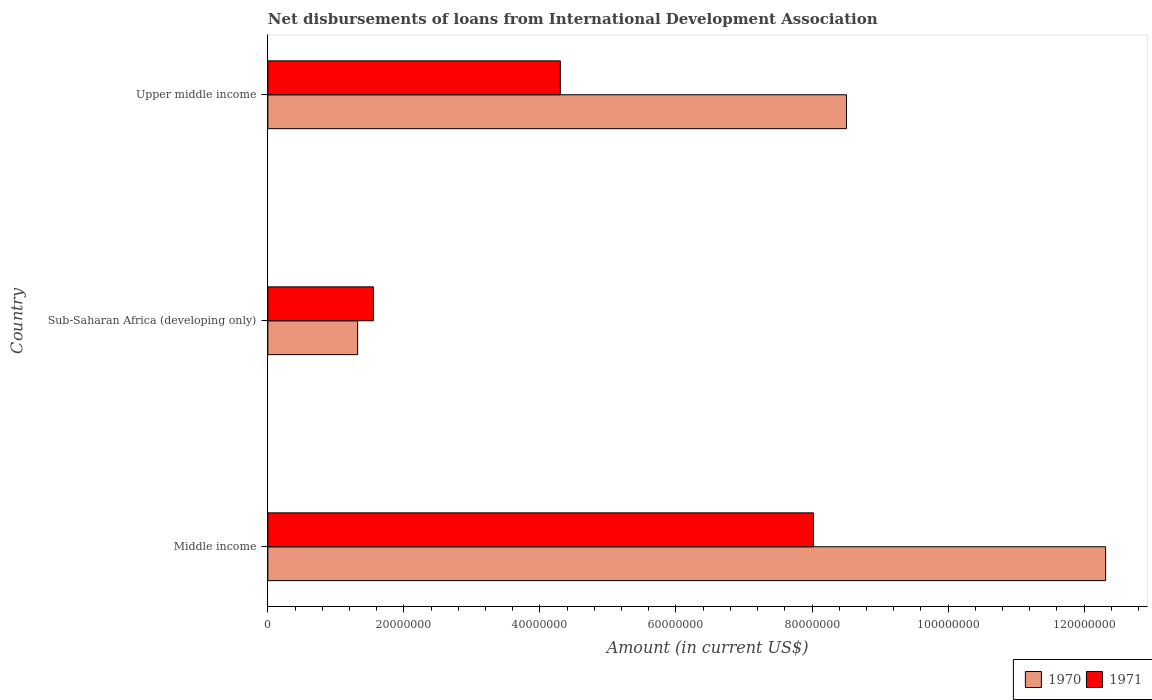How many groups of bars are there?
Make the answer very short. 3. Are the number of bars per tick equal to the number of legend labels?
Your response must be concise. Yes. Are the number of bars on each tick of the Y-axis equal?
Keep it short and to the point. Yes. How many bars are there on the 2nd tick from the top?
Your answer should be compact. 2. In how many cases, is the number of bars for a given country not equal to the number of legend labels?
Your response must be concise. 0. What is the amount of loans disbursed in 1971 in Middle income?
Provide a succinct answer. 8.02e+07. Across all countries, what is the maximum amount of loans disbursed in 1971?
Offer a very short reply. 8.02e+07. Across all countries, what is the minimum amount of loans disbursed in 1970?
Offer a very short reply. 1.32e+07. In which country was the amount of loans disbursed in 1970 minimum?
Give a very brief answer. Sub-Saharan Africa (developing only). What is the total amount of loans disbursed in 1970 in the graph?
Offer a very short reply. 2.21e+08. What is the difference between the amount of loans disbursed in 1970 in Middle income and that in Sub-Saharan Africa (developing only)?
Your response must be concise. 1.10e+08. What is the difference between the amount of loans disbursed in 1971 in Upper middle income and the amount of loans disbursed in 1970 in Sub-Saharan Africa (developing only)?
Your answer should be compact. 2.98e+07. What is the average amount of loans disbursed in 1970 per country?
Your answer should be very brief. 7.38e+07. What is the difference between the amount of loans disbursed in 1971 and amount of loans disbursed in 1970 in Sub-Saharan Africa (developing only)?
Provide a succinct answer. 2.31e+06. In how many countries, is the amount of loans disbursed in 1971 greater than 4000000 US$?
Keep it short and to the point. 3. What is the ratio of the amount of loans disbursed in 1970 in Sub-Saharan Africa (developing only) to that in Upper middle income?
Offer a terse response. 0.16. Is the amount of loans disbursed in 1970 in Middle income less than that in Sub-Saharan Africa (developing only)?
Provide a short and direct response. No. Is the difference between the amount of loans disbursed in 1971 in Middle income and Upper middle income greater than the difference between the amount of loans disbursed in 1970 in Middle income and Upper middle income?
Your response must be concise. No. What is the difference between the highest and the second highest amount of loans disbursed in 1971?
Give a very brief answer. 3.72e+07. What is the difference between the highest and the lowest amount of loans disbursed in 1970?
Your response must be concise. 1.10e+08. In how many countries, is the amount of loans disbursed in 1970 greater than the average amount of loans disbursed in 1970 taken over all countries?
Keep it short and to the point. 2. Is the sum of the amount of loans disbursed in 1970 in Middle income and Sub-Saharan Africa (developing only) greater than the maximum amount of loans disbursed in 1971 across all countries?
Provide a short and direct response. Yes. What does the 1st bar from the top in Middle income represents?
Ensure brevity in your answer.  1971. What does the 1st bar from the bottom in Upper middle income represents?
Make the answer very short. 1970. How many countries are there in the graph?
Keep it short and to the point. 3. What is the difference between two consecutive major ticks on the X-axis?
Make the answer very short. 2.00e+07. Are the values on the major ticks of X-axis written in scientific E-notation?
Offer a terse response. No. How many legend labels are there?
Offer a terse response. 2. How are the legend labels stacked?
Your answer should be very brief. Horizontal. What is the title of the graph?
Keep it short and to the point. Net disbursements of loans from International Development Association. Does "1975" appear as one of the legend labels in the graph?
Ensure brevity in your answer.  No. What is the label or title of the X-axis?
Your answer should be compact. Amount (in current US$). What is the Amount (in current US$) of 1970 in Middle income?
Provide a short and direct response. 1.23e+08. What is the Amount (in current US$) in 1971 in Middle income?
Make the answer very short. 8.02e+07. What is the Amount (in current US$) in 1970 in Sub-Saharan Africa (developing only)?
Your answer should be very brief. 1.32e+07. What is the Amount (in current US$) of 1971 in Sub-Saharan Africa (developing only)?
Your answer should be compact. 1.55e+07. What is the Amount (in current US$) of 1970 in Upper middle income?
Provide a short and direct response. 8.51e+07. What is the Amount (in current US$) in 1971 in Upper middle income?
Your response must be concise. 4.30e+07. Across all countries, what is the maximum Amount (in current US$) in 1970?
Ensure brevity in your answer.  1.23e+08. Across all countries, what is the maximum Amount (in current US$) of 1971?
Your answer should be very brief. 8.02e+07. Across all countries, what is the minimum Amount (in current US$) in 1970?
Your answer should be compact. 1.32e+07. Across all countries, what is the minimum Amount (in current US$) in 1971?
Ensure brevity in your answer.  1.55e+07. What is the total Amount (in current US$) of 1970 in the graph?
Make the answer very short. 2.21e+08. What is the total Amount (in current US$) in 1971 in the graph?
Offer a very short reply. 1.39e+08. What is the difference between the Amount (in current US$) in 1970 in Middle income and that in Sub-Saharan Africa (developing only)?
Make the answer very short. 1.10e+08. What is the difference between the Amount (in current US$) of 1971 in Middle income and that in Sub-Saharan Africa (developing only)?
Your answer should be very brief. 6.47e+07. What is the difference between the Amount (in current US$) in 1970 in Middle income and that in Upper middle income?
Offer a very short reply. 3.81e+07. What is the difference between the Amount (in current US$) of 1971 in Middle income and that in Upper middle income?
Provide a succinct answer. 3.72e+07. What is the difference between the Amount (in current US$) of 1970 in Sub-Saharan Africa (developing only) and that in Upper middle income?
Your response must be concise. -7.19e+07. What is the difference between the Amount (in current US$) in 1971 in Sub-Saharan Africa (developing only) and that in Upper middle income?
Keep it short and to the point. -2.75e+07. What is the difference between the Amount (in current US$) in 1970 in Middle income and the Amount (in current US$) in 1971 in Sub-Saharan Africa (developing only)?
Your answer should be very brief. 1.08e+08. What is the difference between the Amount (in current US$) in 1970 in Middle income and the Amount (in current US$) in 1971 in Upper middle income?
Provide a short and direct response. 8.02e+07. What is the difference between the Amount (in current US$) of 1970 in Sub-Saharan Africa (developing only) and the Amount (in current US$) of 1971 in Upper middle income?
Make the answer very short. -2.98e+07. What is the average Amount (in current US$) in 1970 per country?
Offer a very short reply. 7.38e+07. What is the average Amount (in current US$) of 1971 per country?
Provide a succinct answer. 4.62e+07. What is the difference between the Amount (in current US$) in 1970 and Amount (in current US$) in 1971 in Middle income?
Ensure brevity in your answer.  4.30e+07. What is the difference between the Amount (in current US$) in 1970 and Amount (in current US$) in 1971 in Sub-Saharan Africa (developing only)?
Offer a very short reply. -2.31e+06. What is the difference between the Amount (in current US$) of 1970 and Amount (in current US$) of 1971 in Upper middle income?
Ensure brevity in your answer.  4.21e+07. What is the ratio of the Amount (in current US$) in 1970 in Middle income to that in Sub-Saharan Africa (developing only)?
Your answer should be very brief. 9.33. What is the ratio of the Amount (in current US$) in 1971 in Middle income to that in Sub-Saharan Africa (developing only)?
Give a very brief answer. 5.17. What is the ratio of the Amount (in current US$) in 1970 in Middle income to that in Upper middle income?
Keep it short and to the point. 1.45. What is the ratio of the Amount (in current US$) of 1971 in Middle income to that in Upper middle income?
Your answer should be compact. 1.87. What is the ratio of the Amount (in current US$) of 1970 in Sub-Saharan Africa (developing only) to that in Upper middle income?
Provide a succinct answer. 0.16. What is the ratio of the Amount (in current US$) of 1971 in Sub-Saharan Africa (developing only) to that in Upper middle income?
Give a very brief answer. 0.36. What is the difference between the highest and the second highest Amount (in current US$) in 1970?
Your response must be concise. 3.81e+07. What is the difference between the highest and the second highest Amount (in current US$) in 1971?
Provide a short and direct response. 3.72e+07. What is the difference between the highest and the lowest Amount (in current US$) in 1970?
Give a very brief answer. 1.10e+08. What is the difference between the highest and the lowest Amount (in current US$) in 1971?
Make the answer very short. 6.47e+07. 